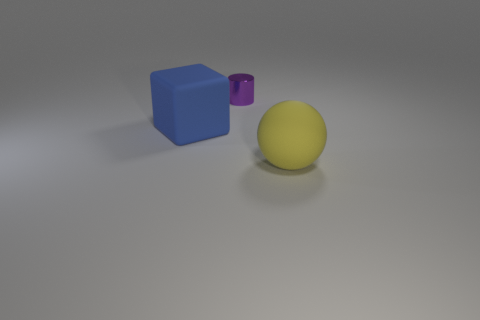What textures are present on the surfaces of the objects? The objects in the image appear to have a matte finish, with the big blue cube and the purple cylinder showing a smooth, non-reflective surface, while the big yellow sphere has a slight soft sheen suggesting a subtle texture. 